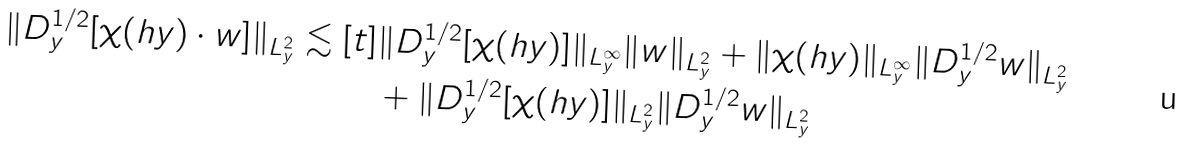Convert formula to latex. <formula><loc_0><loc_0><loc_500><loc_500>\| D _ { y } ^ { 1 / 2 } [ \chi ( h y ) \cdot w ] \| _ { L _ { y } ^ { 2 } } \lesssim [ t ] & \| D _ { y } ^ { 1 / 2 } [ \chi ( h y ) ] \| _ { L _ { y } ^ { \infty } } \| w \| _ { L _ { y } ^ { 2 } } + \| \chi ( h y ) \| _ { L _ { y } ^ { \infty } } \| D _ { y } ^ { 1 / 2 } w \| _ { L _ { y } ^ { 2 } } \\ & + \| D _ { y } ^ { 1 / 2 } [ \chi ( h y ) ] \| _ { L _ { y } ^ { 2 } } \| D _ { y } ^ { 1 / 2 } w \| _ { L _ { y } ^ { 2 } }</formula> 